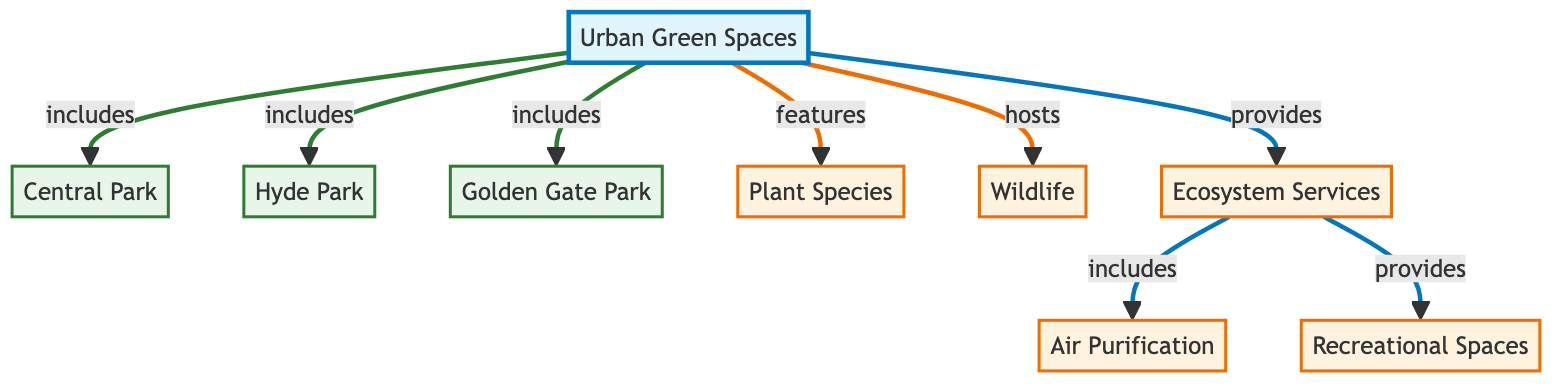What are the three parks included in Urban Green Spaces? The diagram shows three parks under the Urban Green Spaces node: Central Park, Hyde Park, and Golden Gate Park. This information can be found directly connected to the UGS node in the diagram.
Answer: Central Park, Hyde Park, Golden Gate Park What do Urban Green Spaces provide? According to the diagram, Urban Green Spaces provide Ecosystem Services, denoted by the ES node. This relationship is clearly indicated by the directed line from UGS to ES.
Answer: Ecosystem Services How many types of ecosystem services are mentioned in the diagram? The diagram specifies two ecosystem services under the ES node: Air Purification and Recreational Spaces. This indicates the number of different types is two based on the connections from ES.
Answer: Two Which park is the first listed under Urban Green Spaces? The diagram visually positions Central Park first among the listed parks connected to the UGS node. The arrangement of nodes follows a specific order, and Central Park is the topmost.
Answer: Central Park What is one of the ecosystem services provided by Urban Green Spaces? From the diagram, Air Purification is listed as one of the services provided under the ES node. The direct connection indicating this service is clear from the diagram structure.
Answer: Air Purification How many total parks are listed in the diagram? The diagram lists three parks in total: Central Park, Hyde Park, and Golden Gate Park. Each park is directly connected to the main UGS node showing their inclusion.
Answer: Three What do Wildlife and Ecosystem Services connect to in the diagram? Wildlife and Ecosystem Services both connect to the Urban Green Spaces node. This indicates their respective roles as elements contained within the broader UGS category in the diagram.
Answer: Urban Green Spaces Which park connects to the node for Wildlife? The diagram does not specify a park directly linked to Wildlife; instead, it indicates that Wildlife is one of the features of the UGS without further connections to the individual parks.
Answer: None 